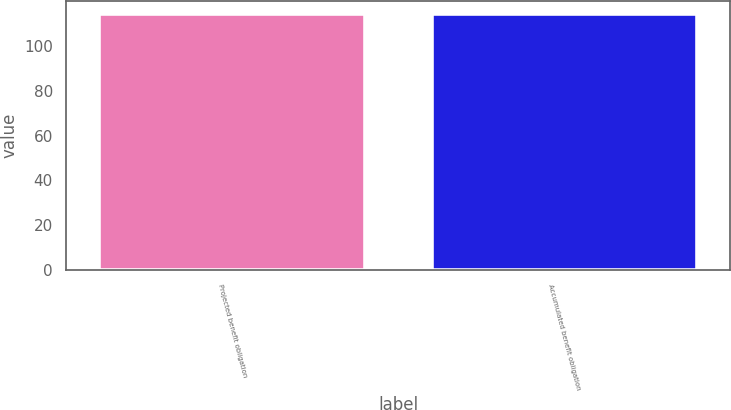<chart> <loc_0><loc_0><loc_500><loc_500><bar_chart><fcel>Projected benefit obligation<fcel>Accumulated benefit obligation<nl><fcel>114<fcel>114.1<nl></chart> 